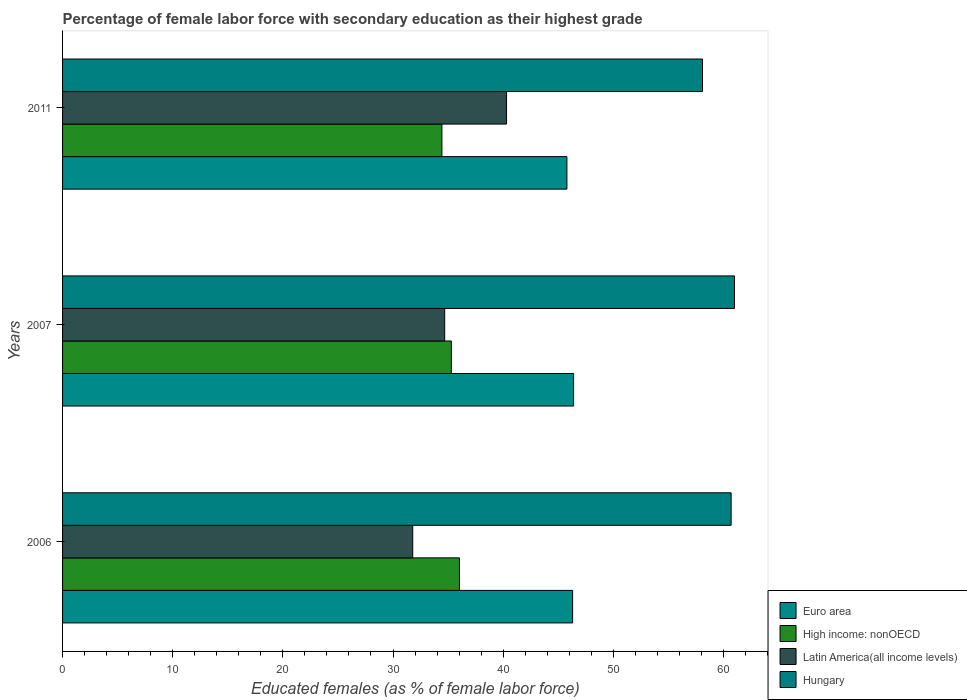How many different coloured bars are there?
Ensure brevity in your answer.  4. How many groups of bars are there?
Your answer should be very brief. 3. How many bars are there on the 2nd tick from the top?
Give a very brief answer. 4. How many bars are there on the 3rd tick from the bottom?
Your response must be concise. 4. What is the label of the 3rd group of bars from the top?
Make the answer very short. 2006. In how many cases, is the number of bars for a given year not equal to the number of legend labels?
Give a very brief answer. 0. What is the percentage of female labor force with secondary education in Hungary in 2011?
Your answer should be very brief. 58.1. Across all years, what is the maximum percentage of female labor force with secondary education in Hungary?
Provide a short and direct response. 61. Across all years, what is the minimum percentage of female labor force with secondary education in Latin America(all income levels)?
Ensure brevity in your answer.  31.79. In which year was the percentage of female labor force with secondary education in Hungary minimum?
Offer a very short reply. 2011. What is the total percentage of female labor force with secondary education in Latin America(all income levels) in the graph?
Ensure brevity in your answer.  106.79. What is the difference between the percentage of female labor force with secondary education in High income: nonOECD in 2007 and that in 2011?
Give a very brief answer. 0.86. What is the difference between the percentage of female labor force with secondary education in Euro area in 2006 and the percentage of female labor force with secondary education in High income: nonOECD in 2007?
Ensure brevity in your answer.  11.01. What is the average percentage of female labor force with secondary education in Hungary per year?
Your answer should be compact. 59.93. In the year 2011, what is the difference between the percentage of female labor force with secondary education in Hungary and percentage of female labor force with secondary education in Euro area?
Your response must be concise. 12.31. What is the ratio of the percentage of female labor force with secondary education in High income: nonOECD in 2007 to that in 2011?
Make the answer very short. 1.02. Is the difference between the percentage of female labor force with secondary education in Hungary in 2006 and 2011 greater than the difference between the percentage of female labor force with secondary education in Euro area in 2006 and 2011?
Offer a very short reply. Yes. What is the difference between the highest and the second highest percentage of female labor force with secondary education in Hungary?
Offer a very short reply. 0.3. What is the difference between the highest and the lowest percentage of female labor force with secondary education in Latin America(all income levels)?
Offer a very short reply. 8.52. What does the 2nd bar from the top in 2007 represents?
Keep it short and to the point. Latin America(all income levels). What does the 4th bar from the bottom in 2007 represents?
Your answer should be very brief. Hungary. Is it the case that in every year, the sum of the percentage of female labor force with secondary education in Euro area and percentage of female labor force with secondary education in Hungary is greater than the percentage of female labor force with secondary education in High income: nonOECD?
Offer a terse response. Yes. How many bars are there?
Your answer should be compact. 12. Where does the legend appear in the graph?
Provide a short and direct response. Bottom right. How many legend labels are there?
Offer a very short reply. 4. What is the title of the graph?
Provide a succinct answer. Percentage of female labor force with secondary education as their highest grade. Does "Tunisia" appear as one of the legend labels in the graph?
Your response must be concise. No. What is the label or title of the X-axis?
Your answer should be very brief. Educated females (as % of female labor force). What is the Educated females (as % of female labor force) of Euro area in 2006?
Provide a succinct answer. 46.31. What is the Educated females (as % of female labor force) of High income: nonOECD in 2006?
Your answer should be very brief. 36.03. What is the Educated females (as % of female labor force) of Latin America(all income levels) in 2006?
Make the answer very short. 31.79. What is the Educated females (as % of female labor force) in Hungary in 2006?
Ensure brevity in your answer.  60.7. What is the Educated females (as % of female labor force) in Euro area in 2007?
Provide a short and direct response. 46.4. What is the Educated females (as % of female labor force) in High income: nonOECD in 2007?
Offer a terse response. 35.3. What is the Educated females (as % of female labor force) of Latin America(all income levels) in 2007?
Offer a terse response. 34.69. What is the Educated females (as % of female labor force) in Hungary in 2007?
Your answer should be compact. 61. What is the Educated females (as % of female labor force) of Euro area in 2011?
Give a very brief answer. 45.79. What is the Educated females (as % of female labor force) in High income: nonOECD in 2011?
Offer a very short reply. 34.44. What is the Educated females (as % of female labor force) of Latin America(all income levels) in 2011?
Keep it short and to the point. 40.31. What is the Educated females (as % of female labor force) in Hungary in 2011?
Offer a very short reply. 58.1. Across all years, what is the maximum Educated females (as % of female labor force) in Euro area?
Your answer should be very brief. 46.4. Across all years, what is the maximum Educated females (as % of female labor force) in High income: nonOECD?
Keep it short and to the point. 36.03. Across all years, what is the maximum Educated females (as % of female labor force) of Latin America(all income levels)?
Keep it short and to the point. 40.31. Across all years, what is the minimum Educated females (as % of female labor force) of Euro area?
Offer a terse response. 45.79. Across all years, what is the minimum Educated females (as % of female labor force) of High income: nonOECD?
Make the answer very short. 34.44. Across all years, what is the minimum Educated females (as % of female labor force) of Latin America(all income levels)?
Offer a terse response. 31.79. Across all years, what is the minimum Educated females (as % of female labor force) in Hungary?
Provide a succinct answer. 58.1. What is the total Educated females (as % of female labor force) in Euro area in the graph?
Make the answer very short. 138.49. What is the total Educated females (as % of female labor force) in High income: nonOECD in the graph?
Give a very brief answer. 105.77. What is the total Educated females (as % of female labor force) in Latin America(all income levels) in the graph?
Make the answer very short. 106.79. What is the total Educated females (as % of female labor force) of Hungary in the graph?
Offer a very short reply. 179.8. What is the difference between the Educated females (as % of female labor force) of Euro area in 2006 and that in 2007?
Your answer should be very brief. -0.09. What is the difference between the Educated females (as % of female labor force) of High income: nonOECD in 2006 and that in 2007?
Ensure brevity in your answer.  0.74. What is the difference between the Educated females (as % of female labor force) in Latin America(all income levels) in 2006 and that in 2007?
Offer a terse response. -2.9. What is the difference between the Educated females (as % of female labor force) in Hungary in 2006 and that in 2007?
Ensure brevity in your answer.  -0.3. What is the difference between the Educated females (as % of female labor force) in Euro area in 2006 and that in 2011?
Offer a very short reply. 0.52. What is the difference between the Educated females (as % of female labor force) in High income: nonOECD in 2006 and that in 2011?
Ensure brevity in your answer.  1.59. What is the difference between the Educated females (as % of female labor force) in Latin America(all income levels) in 2006 and that in 2011?
Make the answer very short. -8.52. What is the difference between the Educated females (as % of female labor force) of Euro area in 2007 and that in 2011?
Make the answer very short. 0.61. What is the difference between the Educated females (as % of female labor force) of High income: nonOECD in 2007 and that in 2011?
Your answer should be compact. 0.86. What is the difference between the Educated females (as % of female labor force) of Latin America(all income levels) in 2007 and that in 2011?
Provide a short and direct response. -5.62. What is the difference between the Educated females (as % of female labor force) in Euro area in 2006 and the Educated females (as % of female labor force) in High income: nonOECD in 2007?
Your answer should be compact. 11.01. What is the difference between the Educated females (as % of female labor force) in Euro area in 2006 and the Educated females (as % of female labor force) in Latin America(all income levels) in 2007?
Your answer should be very brief. 11.61. What is the difference between the Educated females (as % of female labor force) in Euro area in 2006 and the Educated females (as % of female labor force) in Hungary in 2007?
Keep it short and to the point. -14.69. What is the difference between the Educated females (as % of female labor force) of High income: nonOECD in 2006 and the Educated females (as % of female labor force) of Latin America(all income levels) in 2007?
Offer a very short reply. 1.34. What is the difference between the Educated females (as % of female labor force) in High income: nonOECD in 2006 and the Educated females (as % of female labor force) in Hungary in 2007?
Your response must be concise. -24.97. What is the difference between the Educated females (as % of female labor force) of Latin America(all income levels) in 2006 and the Educated females (as % of female labor force) of Hungary in 2007?
Make the answer very short. -29.21. What is the difference between the Educated females (as % of female labor force) in Euro area in 2006 and the Educated females (as % of female labor force) in High income: nonOECD in 2011?
Ensure brevity in your answer.  11.87. What is the difference between the Educated females (as % of female labor force) of Euro area in 2006 and the Educated females (as % of female labor force) of Latin America(all income levels) in 2011?
Give a very brief answer. 6. What is the difference between the Educated females (as % of female labor force) in Euro area in 2006 and the Educated females (as % of female labor force) in Hungary in 2011?
Your response must be concise. -11.79. What is the difference between the Educated females (as % of female labor force) of High income: nonOECD in 2006 and the Educated females (as % of female labor force) of Latin America(all income levels) in 2011?
Your response must be concise. -4.28. What is the difference between the Educated females (as % of female labor force) of High income: nonOECD in 2006 and the Educated females (as % of female labor force) of Hungary in 2011?
Give a very brief answer. -22.07. What is the difference between the Educated females (as % of female labor force) in Latin America(all income levels) in 2006 and the Educated females (as % of female labor force) in Hungary in 2011?
Ensure brevity in your answer.  -26.31. What is the difference between the Educated females (as % of female labor force) of Euro area in 2007 and the Educated females (as % of female labor force) of High income: nonOECD in 2011?
Your response must be concise. 11.96. What is the difference between the Educated females (as % of female labor force) in Euro area in 2007 and the Educated females (as % of female labor force) in Latin America(all income levels) in 2011?
Your answer should be compact. 6.09. What is the difference between the Educated females (as % of female labor force) of Euro area in 2007 and the Educated females (as % of female labor force) of Hungary in 2011?
Offer a terse response. -11.7. What is the difference between the Educated females (as % of female labor force) in High income: nonOECD in 2007 and the Educated females (as % of female labor force) in Latin America(all income levels) in 2011?
Your answer should be compact. -5.01. What is the difference between the Educated females (as % of female labor force) in High income: nonOECD in 2007 and the Educated females (as % of female labor force) in Hungary in 2011?
Your answer should be compact. -22.8. What is the difference between the Educated females (as % of female labor force) of Latin America(all income levels) in 2007 and the Educated females (as % of female labor force) of Hungary in 2011?
Your answer should be very brief. -23.41. What is the average Educated females (as % of female labor force) in Euro area per year?
Your answer should be compact. 46.16. What is the average Educated females (as % of female labor force) in High income: nonOECD per year?
Keep it short and to the point. 35.26. What is the average Educated females (as % of female labor force) in Latin America(all income levels) per year?
Keep it short and to the point. 35.6. What is the average Educated females (as % of female labor force) of Hungary per year?
Provide a short and direct response. 59.93. In the year 2006, what is the difference between the Educated females (as % of female labor force) in Euro area and Educated females (as % of female labor force) in High income: nonOECD?
Provide a succinct answer. 10.27. In the year 2006, what is the difference between the Educated females (as % of female labor force) of Euro area and Educated females (as % of female labor force) of Latin America(all income levels)?
Ensure brevity in your answer.  14.52. In the year 2006, what is the difference between the Educated females (as % of female labor force) of Euro area and Educated females (as % of female labor force) of Hungary?
Provide a short and direct response. -14.39. In the year 2006, what is the difference between the Educated females (as % of female labor force) in High income: nonOECD and Educated females (as % of female labor force) in Latin America(all income levels)?
Make the answer very short. 4.24. In the year 2006, what is the difference between the Educated females (as % of female labor force) of High income: nonOECD and Educated females (as % of female labor force) of Hungary?
Provide a short and direct response. -24.67. In the year 2006, what is the difference between the Educated females (as % of female labor force) in Latin America(all income levels) and Educated females (as % of female labor force) in Hungary?
Provide a short and direct response. -28.91. In the year 2007, what is the difference between the Educated females (as % of female labor force) in Euro area and Educated females (as % of female labor force) in High income: nonOECD?
Make the answer very short. 11.1. In the year 2007, what is the difference between the Educated females (as % of female labor force) in Euro area and Educated females (as % of female labor force) in Latin America(all income levels)?
Your response must be concise. 11.7. In the year 2007, what is the difference between the Educated females (as % of female labor force) of Euro area and Educated females (as % of female labor force) of Hungary?
Offer a very short reply. -14.6. In the year 2007, what is the difference between the Educated females (as % of female labor force) in High income: nonOECD and Educated females (as % of female labor force) in Latin America(all income levels)?
Give a very brief answer. 0.6. In the year 2007, what is the difference between the Educated females (as % of female labor force) in High income: nonOECD and Educated females (as % of female labor force) in Hungary?
Your answer should be compact. -25.7. In the year 2007, what is the difference between the Educated females (as % of female labor force) in Latin America(all income levels) and Educated females (as % of female labor force) in Hungary?
Provide a succinct answer. -26.31. In the year 2011, what is the difference between the Educated females (as % of female labor force) in Euro area and Educated females (as % of female labor force) in High income: nonOECD?
Your answer should be very brief. 11.35. In the year 2011, what is the difference between the Educated females (as % of female labor force) in Euro area and Educated females (as % of female labor force) in Latin America(all income levels)?
Provide a short and direct response. 5.48. In the year 2011, what is the difference between the Educated females (as % of female labor force) of Euro area and Educated females (as % of female labor force) of Hungary?
Your answer should be compact. -12.31. In the year 2011, what is the difference between the Educated females (as % of female labor force) in High income: nonOECD and Educated females (as % of female labor force) in Latin America(all income levels)?
Offer a very short reply. -5.87. In the year 2011, what is the difference between the Educated females (as % of female labor force) of High income: nonOECD and Educated females (as % of female labor force) of Hungary?
Your answer should be compact. -23.66. In the year 2011, what is the difference between the Educated females (as % of female labor force) in Latin America(all income levels) and Educated females (as % of female labor force) in Hungary?
Your answer should be compact. -17.79. What is the ratio of the Educated females (as % of female labor force) in Euro area in 2006 to that in 2007?
Make the answer very short. 1. What is the ratio of the Educated females (as % of female labor force) of High income: nonOECD in 2006 to that in 2007?
Ensure brevity in your answer.  1.02. What is the ratio of the Educated females (as % of female labor force) in Latin America(all income levels) in 2006 to that in 2007?
Your answer should be very brief. 0.92. What is the ratio of the Educated females (as % of female labor force) of Hungary in 2006 to that in 2007?
Provide a succinct answer. 1. What is the ratio of the Educated females (as % of female labor force) of Euro area in 2006 to that in 2011?
Ensure brevity in your answer.  1.01. What is the ratio of the Educated females (as % of female labor force) of High income: nonOECD in 2006 to that in 2011?
Your answer should be compact. 1.05. What is the ratio of the Educated females (as % of female labor force) in Latin America(all income levels) in 2006 to that in 2011?
Your response must be concise. 0.79. What is the ratio of the Educated females (as % of female labor force) of Hungary in 2006 to that in 2011?
Your answer should be compact. 1.04. What is the ratio of the Educated females (as % of female labor force) of Euro area in 2007 to that in 2011?
Provide a succinct answer. 1.01. What is the ratio of the Educated females (as % of female labor force) in High income: nonOECD in 2007 to that in 2011?
Your answer should be compact. 1.02. What is the ratio of the Educated females (as % of female labor force) of Latin America(all income levels) in 2007 to that in 2011?
Offer a very short reply. 0.86. What is the ratio of the Educated females (as % of female labor force) in Hungary in 2007 to that in 2011?
Ensure brevity in your answer.  1.05. What is the difference between the highest and the second highest Educated females (as % of female labor force) of Euro area?
Ensure brevity in your answer.  0.09. What is the difference between the highest and the second highest Educated females (as % of female labor force) of High income: nonOECD?
Your answer should be very brief. 0.74. What is the difference between the highest and the second highest Educated females (as % of female labor force) in Latin America(all income levels)?
Your response must be concise. 5.62. What is the difference between the highest and the lowest Educated females (as % of female labor force) in Euro area?
Provide a short and direct response. 0.61. What is the difference between the highest and the lowest Educated females (as % of female labor force) of High income: nonOECD?
Provide a succinct answer. 1.59. What is the difference between the highest and the lowest Educated females (as % of female labor force) in Latin America(all income levels)?
Your response must be concise. 8.52. 